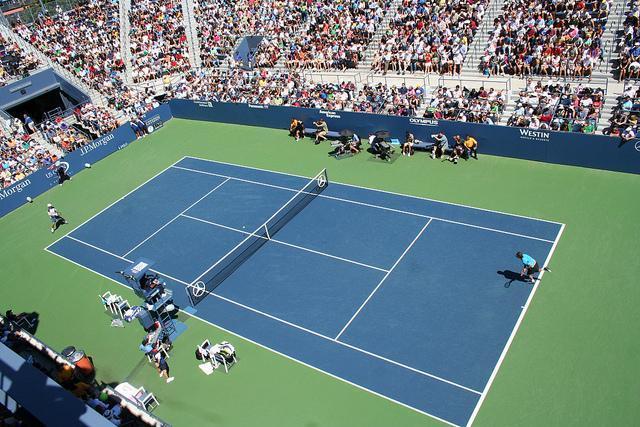How many people are on the court?
Give a very brief answer. 2. 